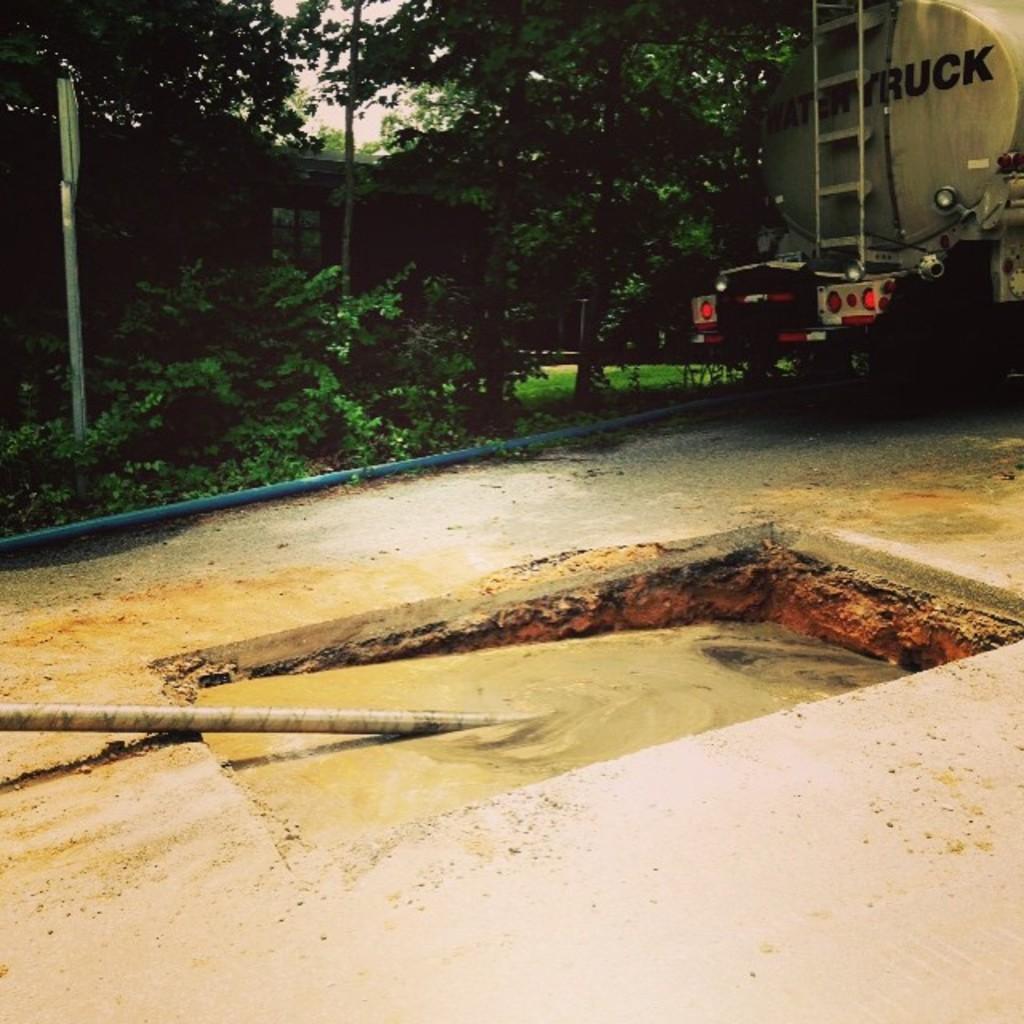Describe this image in one or two sentences. In this image we can see a truck with stair case is placed on the ground. In the center of the image we can see some pipes, signboard, pipes, group of trees. In the background we can see the sky. 